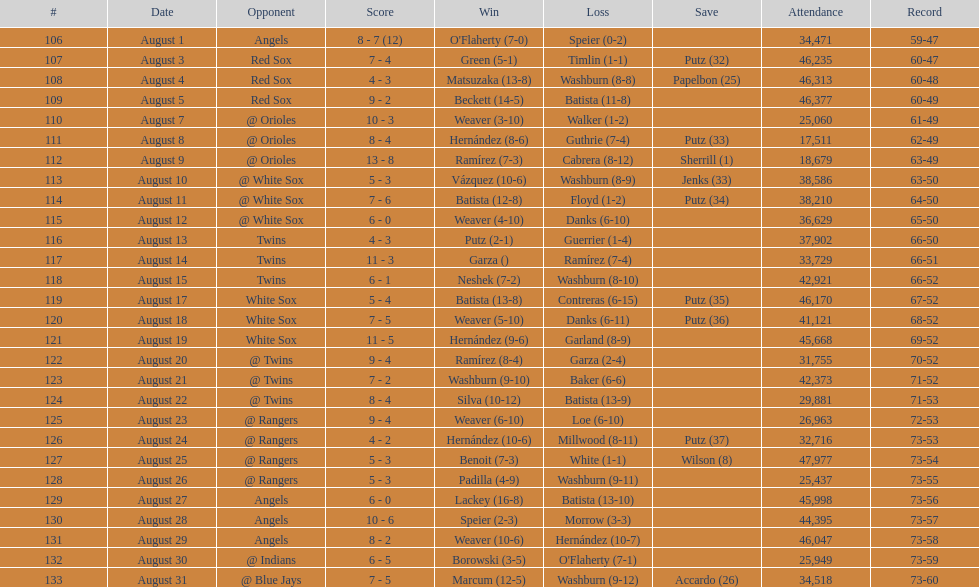Biggest run difference 8. Could you parse the entire table as a dict? {'header': ['#', 'Date', 'Opponent', 'Score', 'Win', 'Loss', 'Save', 'Attendance', 'Record'], 'rows': [['106', 'August 1', 'Angels', '8 - 7 (12)', "O'Flaherty (7-0)", 'Speier (0-2)', '', '34,471', '59-47'], ['107', 'August 3', 'Red Sox', '7 - 4', 'Green (5-1)', 'Timlin (1-1)', 'Putz (32)', '46,235', '60-47'], ['108', 'August 4', 'Red Sox', '4 - 3', 'Matsuzaka (13-8)', 'Washburn (8-8)', 'Papelbon (25)', '46,313', '60-48'], ['109', 'August 5', 'Red Sox', '9 - 2', 'Beckett (14-5)', 'Batista (11-8)', '', '46,377', '60-49'], ['110', 'August 7', '@ Orioles', '10 - 3', 'Weaver (3-10)', 'Walker (1-2)', '', '25,060', '61-49'], ['111', 'August 8', '@ Orioles', '8 - 4', 'Hernández (8-6)', 'Guthrie (7-4)', 'Putz (33)', '17,511', '62-49'], ['112', 'August 9', '@ Orioles', '13 - 8', 'Ramírez (7-3)', 'Cabrera (8-12)', 'Sherrill (1)', '18,679', '63-49'], ['113', 'August 10', '@ White Sox', '5 - 3', 'Vázquez (10-6)', 'Washburn (8-9)', 'Jenks (33)', '38,586', '63-50'], ['114', 'August 11', '@ White Sox', '7 - 6', 'Batista (12-8)', 'Floyd (1-2)', 'Putz (34)', '38,210', '64-50'], ['115', 'August 12', '@ White Sox', '6 - 0', 'Weaver (4-10)', 'Danks (6-10)', '', '36,629', '65-50'], ['116', 'August 13', 'Twins', '4 - 3', 'Putz (2-1)', 'Guerrier (1-4)', '', '37,902', '66-50'], ['117', 'August 14', 'Twins', '11 - 3', 'Garza ()', 'Ramírez (7-4)', '', '33,729', '66-51'], ['118', 'August 15', 'Twins', '6 - 1', 'Neshek (7-2)', 'Washburn (8-10)', '', '42,921', '66-52'], ['119', 'August 17', 'White Sox', '5 - 4', 'Batista (13-8)', 'Contreras (6-15)', 'Putz (35)', '46,170', '67-52'], ['120', 'August 18', 'White Sox', '7 - 5', 'Weaver (5-10)', 'Danks (6-11)', 'Putz (36)', '41,121', '68-52'], ['121', 'August 19', 'White Sox', '11 - 5', 'Hernández (9-6)', 'Garland (8-9)', '', '45,668', '69-52'], ['122', 'August 20', '@ Twins', '9 - 4', 'Ramírez (8-4)', 'Garza (2-4)', '', '31,755', '70-52'], ['123', 'August 21', '@ Twins', '7 - 2', 'Washburn (9-10)', 'Baker (6-6)', '', '42,373', '71-52'], ['124', 'August 22', '@ Twins', '8 - 4', 'Silva (10-12)', 'Batista (13-9)', '', '29,881', '71-53'], ['125', 'August 23', '@ Rangers', '9 - 4', 'Weaver (6-10)', 'Loe (6-10)', '', '26,963', '72-53'], ['126', 'August 24', '@ Rangers', '4 - 2', 'Hernández (10-6)', 'Millwood (8-11)', 'Putz (37)', '32,716', '73-53'], ['127', 'August 25', '@ Rangers', '5 - 3', 'Benoit (7-3)', 'White (1-1)', 'Wilson (8)', '47,977', '73-54'], ['128', 'August 26', '@ Rangers', '5 - 3', 'Padilla (4-9)', 'Washburn (9-11)', '', '25,437', '73-55'], ['129', 'August 27', 'Angels', '6 - 0', 'Lackey (16-8)', 'Batista (13-10)', '', '45,998', '73-56'], ['130', 'August 28', 'Angels', '10 - 6', 'Speier (2-3)', 'Morrow (3-3)', '', '44,395', '73-57'], ['131', 'August 29', 'Angels', '8 - 2', 'Weaver (10-6)', 'Hernández (10-7)', '', '46,047', '73-58'], ['132', 'August 30', '@ Indians', '6 - 5', 'Borowski (3-5)', "O'Flaherty (7-1)", '', '25,949', '73-59'], ['133', 'August 31', '@ Blue Jays', '7 - 5', 'Marcum (12-5)', 'Washburn (9-12)', 'Accardo (26)', '34,518', '73-60']]} 